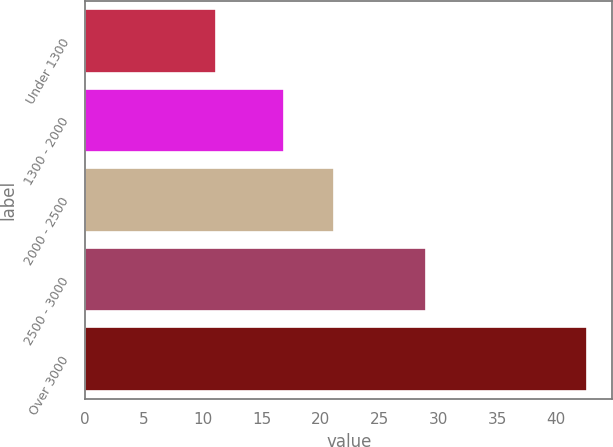Convert chart to OTSL. <chart><loc_0><loc_0><loc_500><loc_500><bar_chart><fcel>Under 1300<fcel>1300 - 2000<fcel>2000 - 2500<fcel>2500 - 3000<fcel>Over 3000<nl><fcel>11.1<fcel>16.88<fcel>21.15<fcel>28.95<fcel>42.66<nl></chart> 